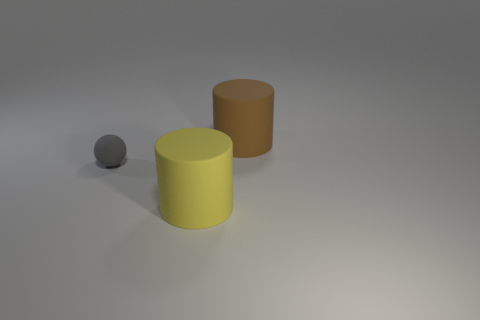Do the matte thing that is in front of the gray ball and the thing that is on the left side of the yellow rubber thing have the same size?
Offer a very short reply. No. There is another cylinder that is made of the same material as the yellow cylinder; what size is it?
Keep it short and to the point. Large. What number of objects are to the right of the tiny gray matte thing and to the left of the big brown thing?
Offer a terse response. 1. How many things are either small cyan rubber spheres or large things that are behind the small rubber object?
Ensure brevity in your answer.  1. There is a matte cylinder that is in front of the tiny gray thing; what color is it?
Keep it short and to the point. Yellow. What number of objects are either large cylinders behind the tiny gray matte ball or large blue matte objects?
Offer a terse response. 1. What is the color of the matte object that is the same size as the yellow rubber cylinder?
Offer a very short reply. Brown. Is the number of things that are to the left of the big brown cylinder greater than the number of yellow blocks?
Ensure brevity in your answer.  Yes. What number of other things are the same size as the gray matte ball?
Ensure brevity in your answer.  0. There is a large thing behind the cylinder that is in front of the big brown cylinder; is there a large cylinder that is on the left side of it?
Provide a short and direct response. Yes. 